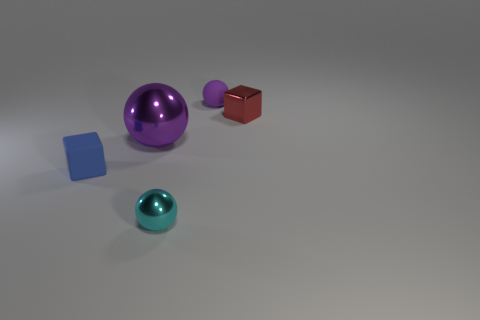There is a tiny thing that is the same color as the large metal sphere; what shape is it?
Your response must be concise. Sphere. Are there any red objects of the same shape as the blue object?
Offer a very short reply. Yes. What is the color of the matte cube that is the same size as the cyan shiny thing?
Give a very brief answer. Blue. There is a small block on the right side of the small thing to the left of the large sphere; what is its color?
Keep it short and to the point. Red. There is a cube left of the cyan metallic object; does it have the same color as the big thing?
Your answer should be compact. No. The small matte object that is in front of the metallic thing behind the purple object that is in front of the tiny purple object is what shape?
Make the answer very short. Cube. There is a matte object that is in front of the tiny purple thing; what number of purple things are behind it?
Offer a very short reply. 2. Does the large purple thing have the same material as the blue thing?
Give a very brief answer. No. There is a rubber thing behind the small block to the right of the blue thing; how many blue rubber things are behind it?
Give a very brief answer. 0. What color is the small cube that is in front of the tiny red thing?
Keep it short and to the point. Blue. 